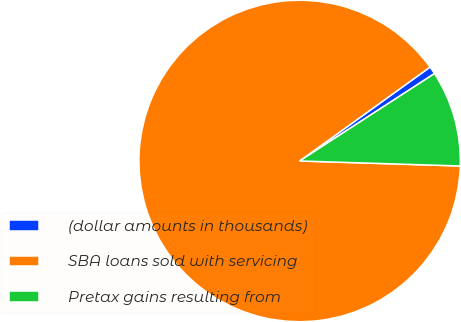Convert chart to OTSL. <chart><loc_0><loc_0><loc_500><loc_500><pie_chart><fcel>(dollar amounts in thousands)<fcel>SBA loans sold with servicing<fcel>Pretax gains resulting from<nl><fcel>0.78%<fcel>89.57%<fcel>9.65%<nl></chart> 